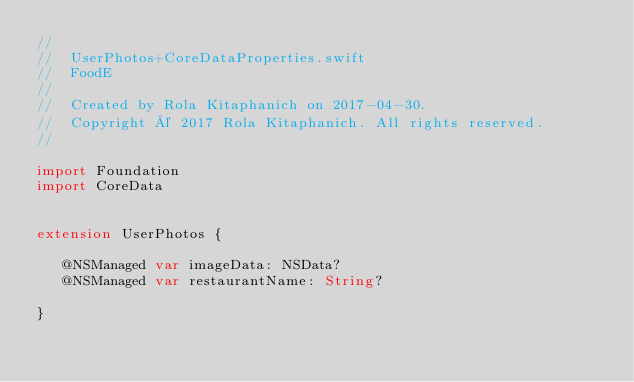Convert code to text. <code><loc_0><loc_0><loc_500><loc_500><_Swift_>//
//  UserPhotos+CoreDataProperties.swift
//  FoodE
//
//  Created by Rola Kitaphanich on 2017-04-30.
//  Copyright © 2017 Rola Kitaphanich. All rights reserved.
//

import Foundation
import CoreData


extension UserPhotos {

   @NSManaged var imageData: NSData?
   @NSManaged var restaurantName: String?
    
}
</code> 